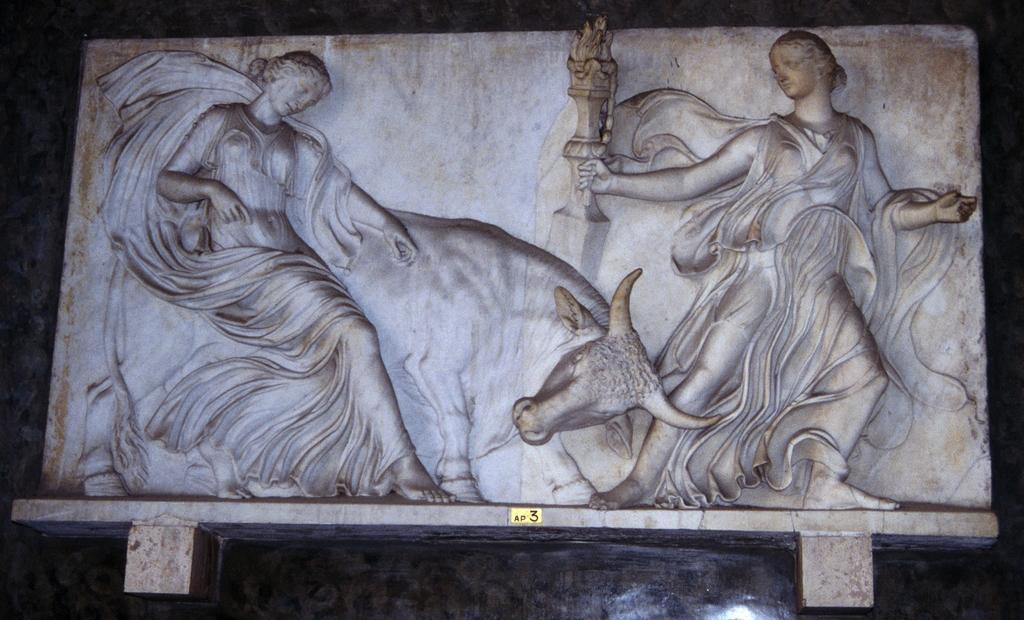How would you summarize this image in a sentence or two? In this picture, we see the stone carved statues of the women and a cow. In the background, it is black in color. 